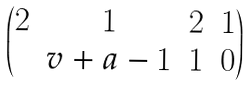Convert formula to latex. <formula><loc_0><loc_0><loc_500><loc_500>\begin{pmatrix} 2 & 1 & 2 & 1 \\ & v + a - 1 & 1 & 0 \end{pmatrix}</formula> 